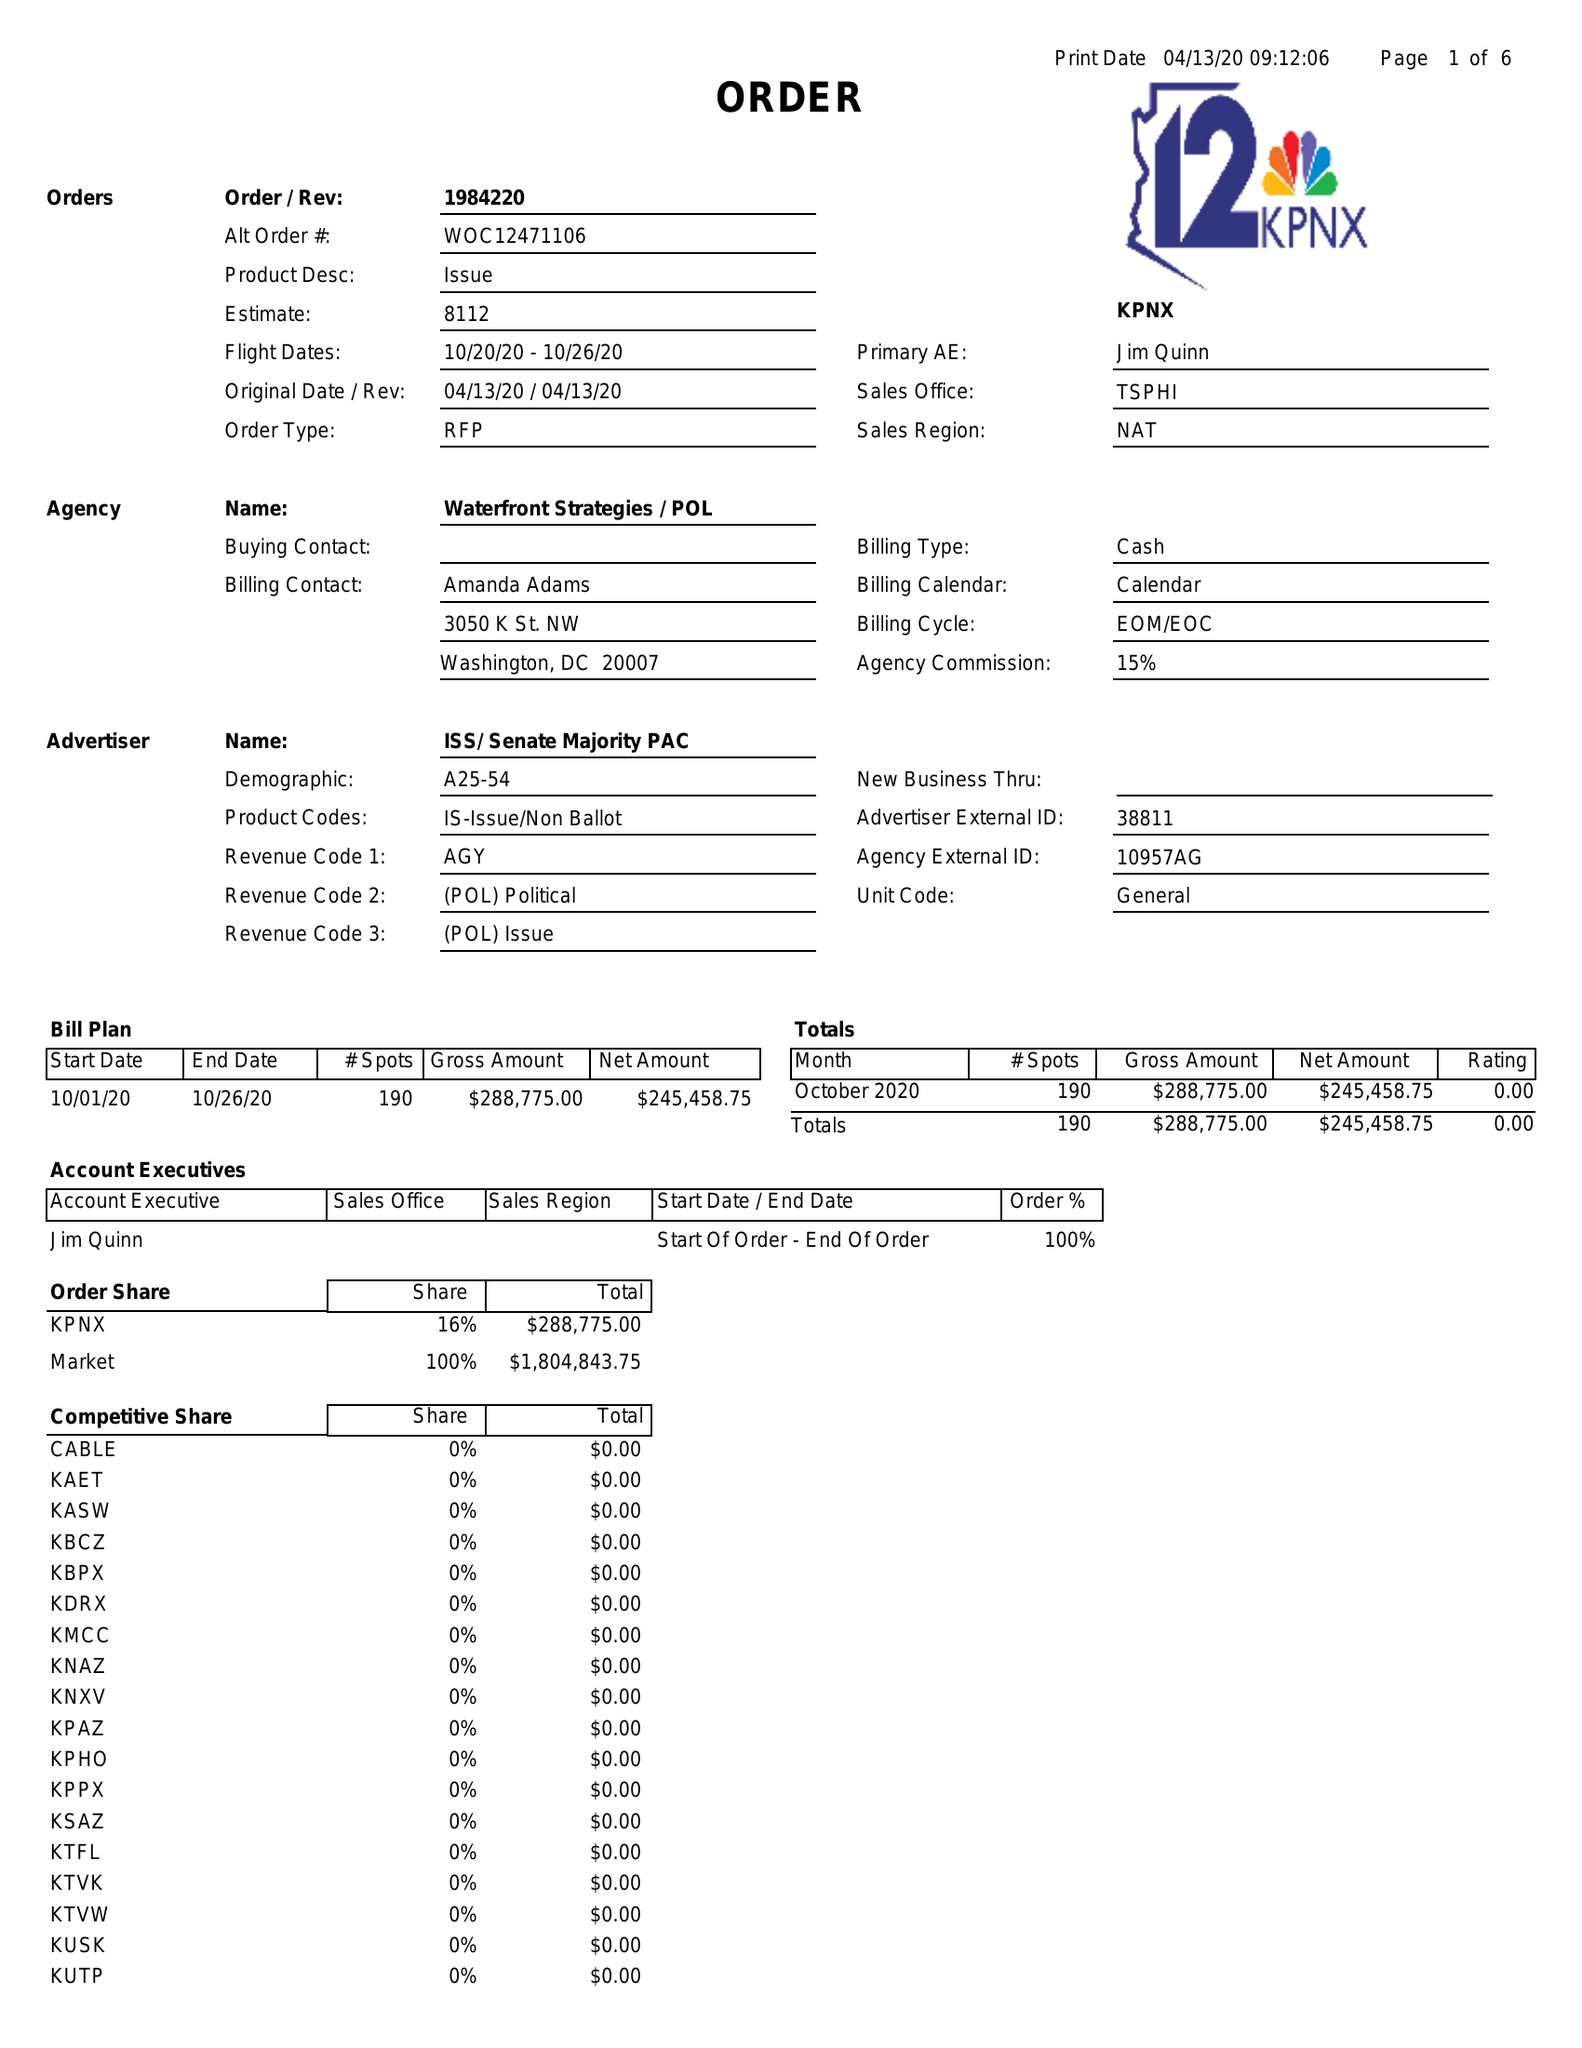What is the value for the contract_num?
Answer the question using a single word or phrase. 1984220 